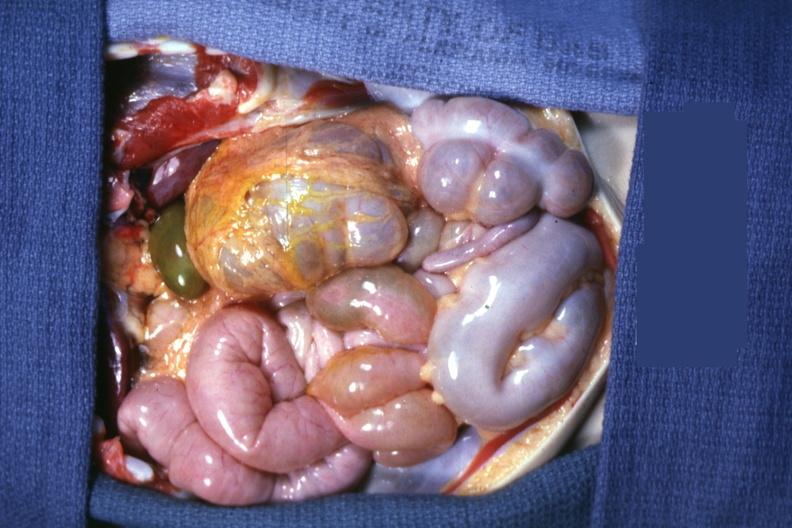what is present?
Answer the question using a single word or phrase. Abdomen 